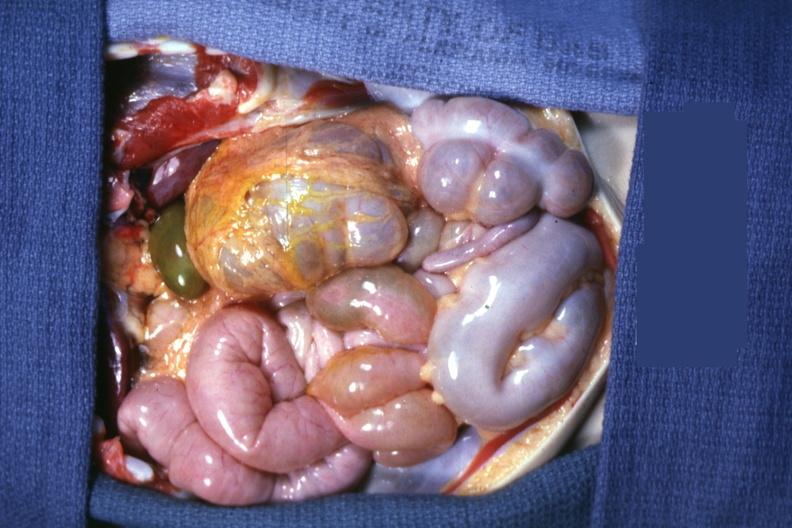what is present?
Answer the question using a single word or phrase. Abdomen 